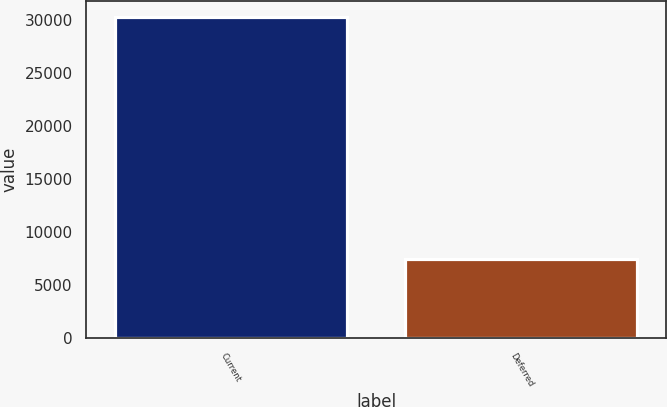<chart> <loc_0><loc_0><loc_500><loc_500><bar_chart><fcel>Current<fcel>Deferred<nl><fcel>30237<fcel>7447<nl></chart> 